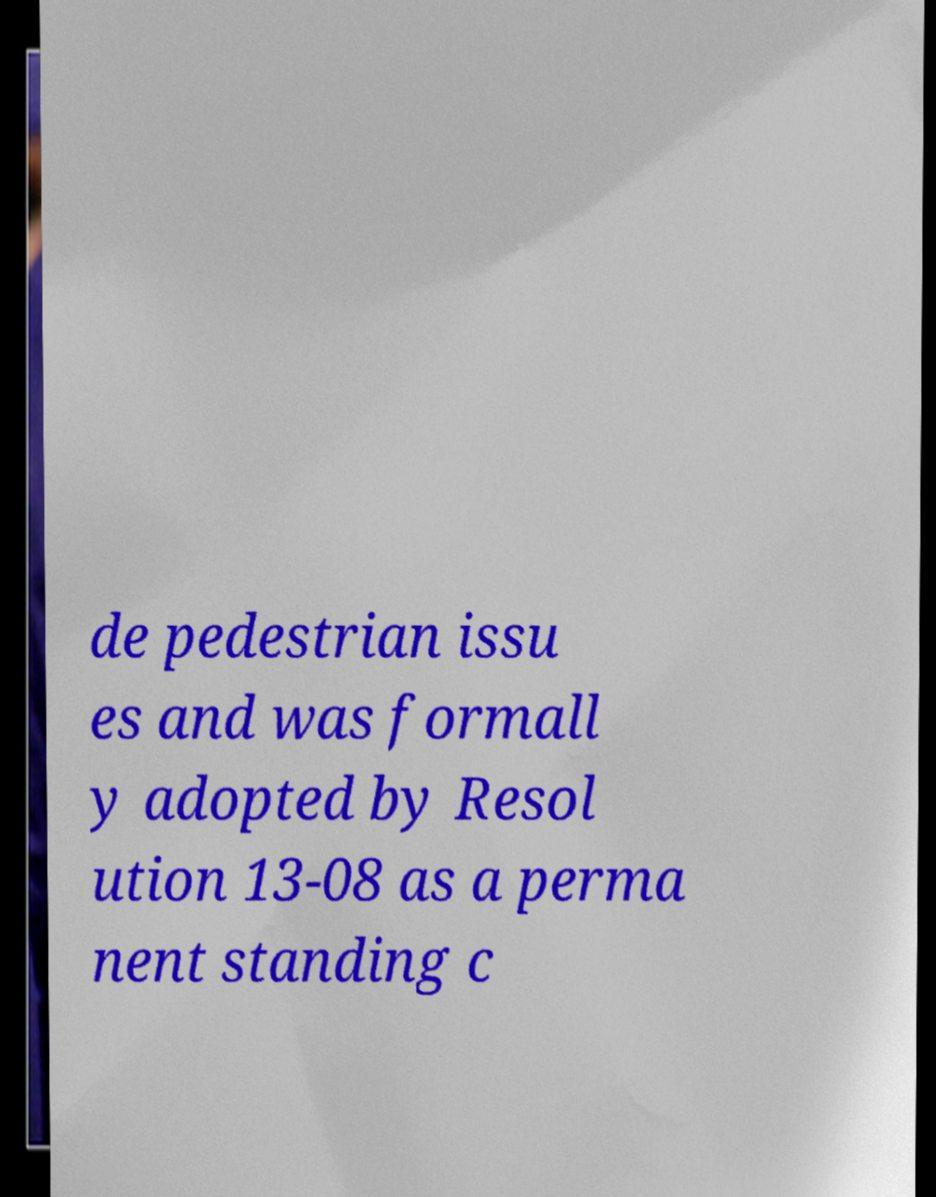What messages or text are displayed in this image? I need them in a readable, typed format. de pedestrian issu es and was formall y adopted by Resol ution 13-08 as a perma nent standing c 